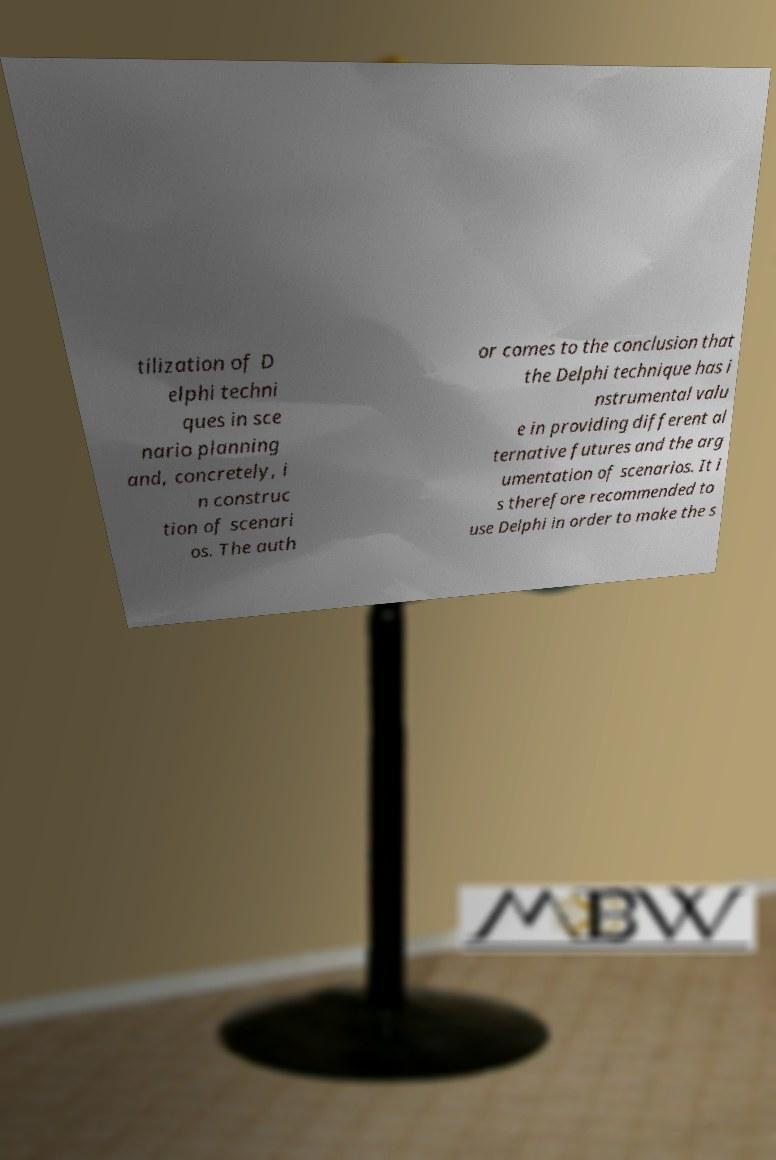What messages or text are displayed in this image? I need them in a readable, typed format. tilization of D elphi techni ques in sce nario planning and, concretely, i n construc tion of scenari os. The auth or comes to the conclusion that the Delphi technique has i nstrumental valu e in providing different al ternative futures and the arg umentation of scenarios. It i s therefore recommended to use Delphi in order to make the s 